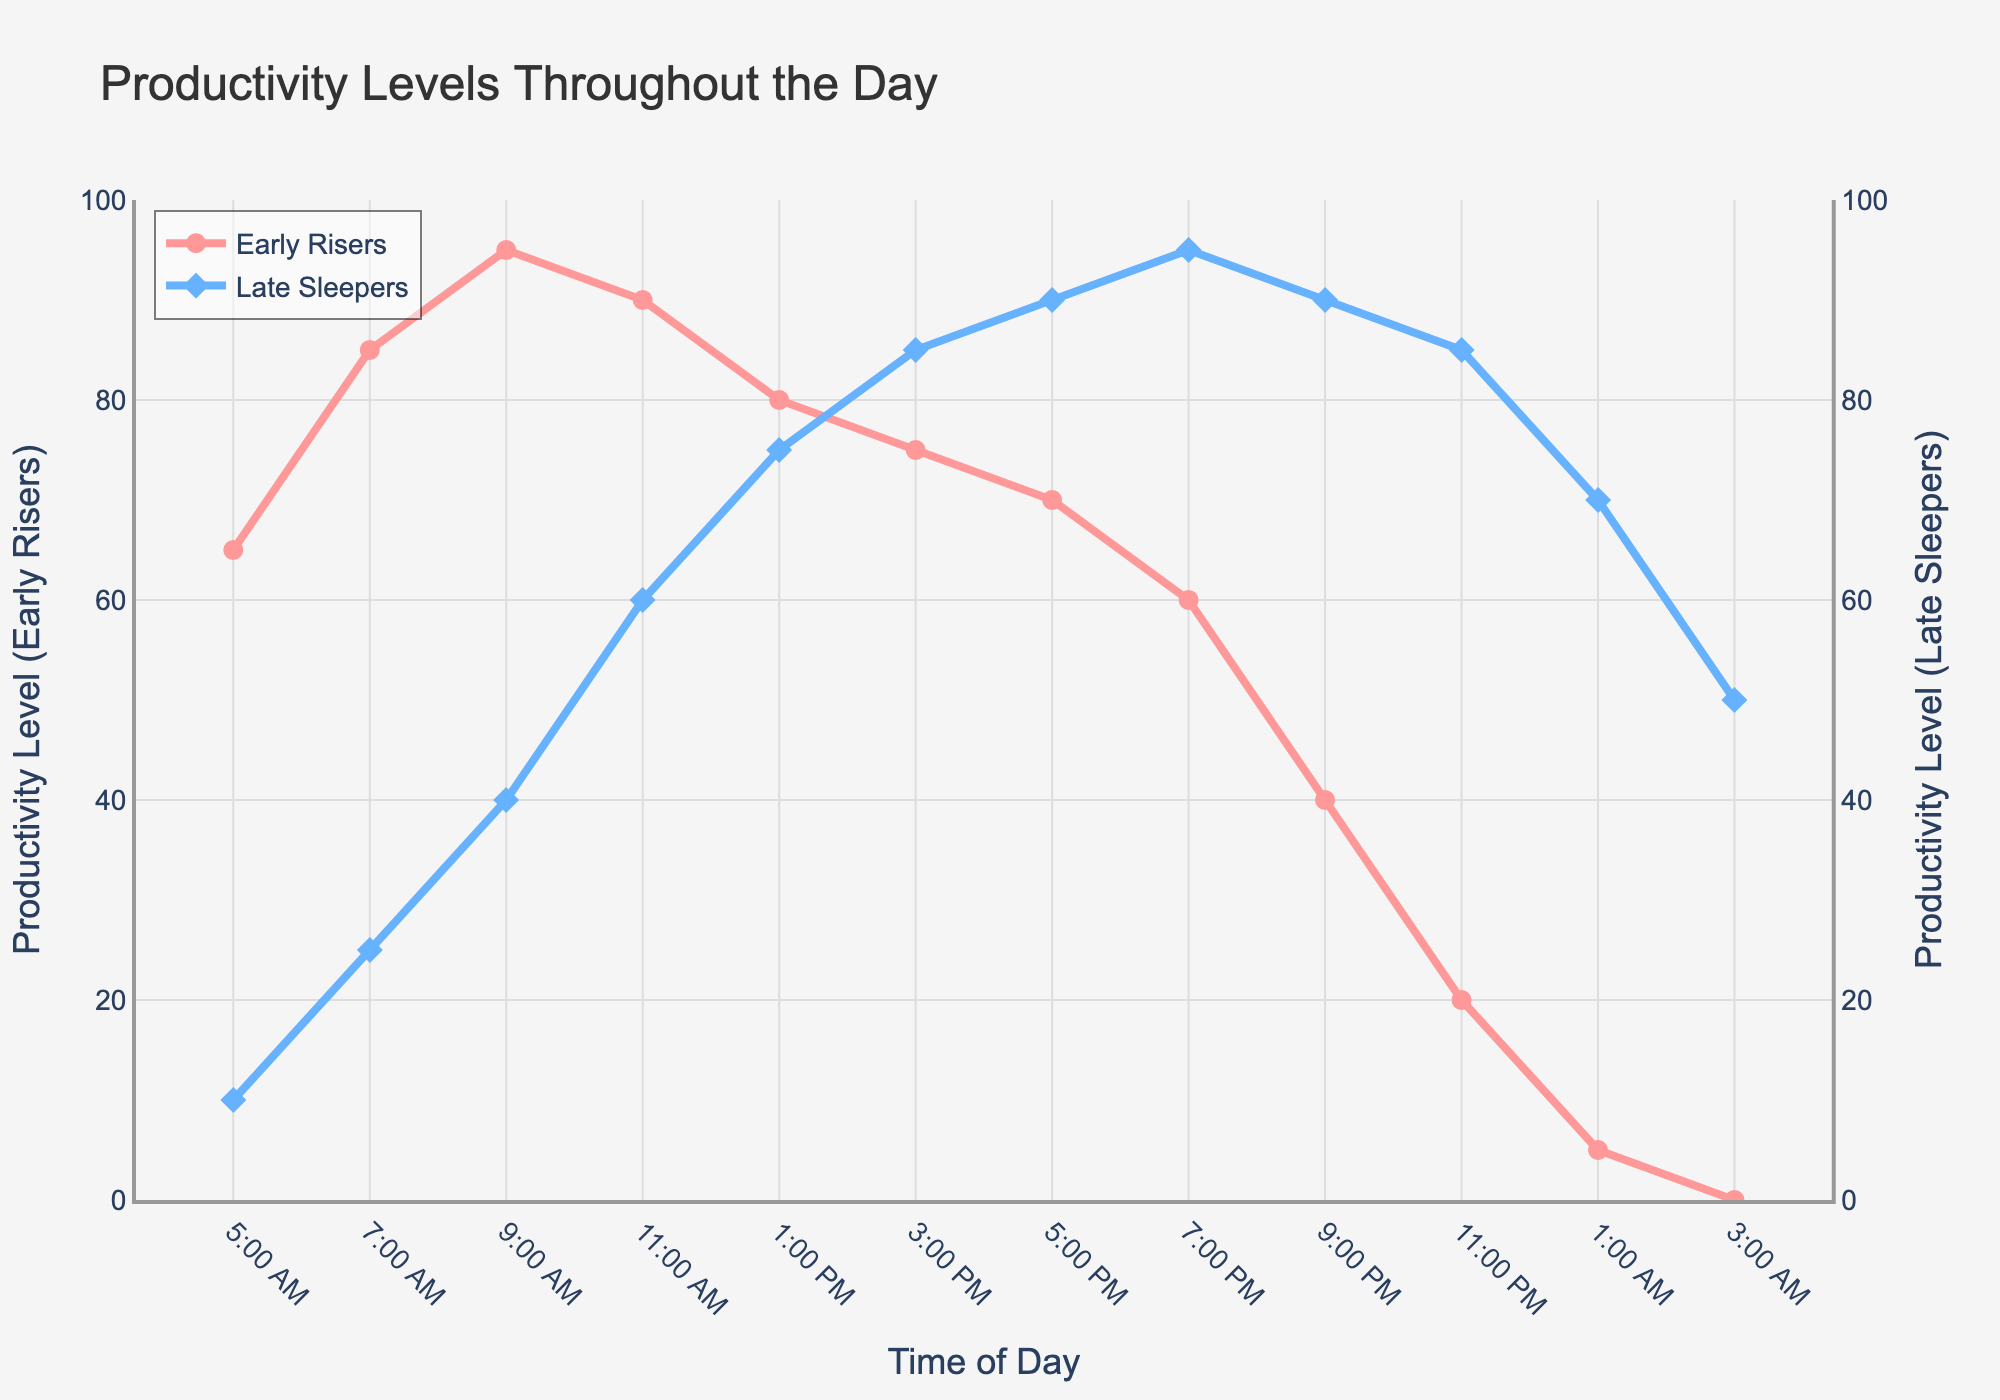What's the productivity level for Early Risers at 9:00 AM? The figure shows the productivity levels at different times of the day, and the value for Early Risers at 9:00 AM can be directly read from the plot.
Answer: 95 At what time does the productivity of Late Sleepers first surpass that of Early Risers? By examining where the blue line for Late Sleepers crosses above the red line for Early Risers, it appears that Late Sleepers’ productivity surpasses Early Risers around 5:00 PM.
Answer: 5:00 PM Which group has a higher productivity level at 11:00 PM? By comparing the two lines at 11:00 PM, it is clear that the Late Sleepers (blue line) have a higher productivity level than the Early Risers (red line).
Answer: Late Sleepers What is the difference in productivity levels between Early Risers and Late Sleepers at 1:00 AM? At 1:00 AM, the productivity level for Early Risers is 5, and for Late Sleepers, it is 70. The difference is calculated as 70 - 5.
Answer: 65 How does the productivity level for Early Risers change from 5:00 AM to 11:00 AM? The productivity level for Early Risers increases from 65 at 5:00 AM to 95 at 9:00 AM and then slightly decreases to 90 at 11:00 AM.
Answer: Increases, then decreases What time range shows the maximum productivity for Early Risers? By observing the red line peaks, the maximum productivity for Early Risers appears between 7:00 AM and 9:00 AM.
Answer: 7:00 AM - 9:00 AM How many hours is the productivity of Late Sleepers above 80? By looking at the plot, the productivity of Late Sleepers is above 80 from 5:00 PM to 3:00 AM. This is a total of 10 hours.
Answer: 10 hours What is the average productivity level for Early Risers between 3:00 PM and 9:00 PM? The productivity levels between 3:00 PM and 9:00 PM for Early Risers are 75, 70, and 60. The average is calculated as (75 + 70 + 60) / 3.
Answer: 68.33 Identify the time period when both groups have similar productivity levels. The lines for both groups are closest between 1:00 PM and 5:00 PM where their productivity levels converge.
Answer: 1:00 PM - 5:00 PM 